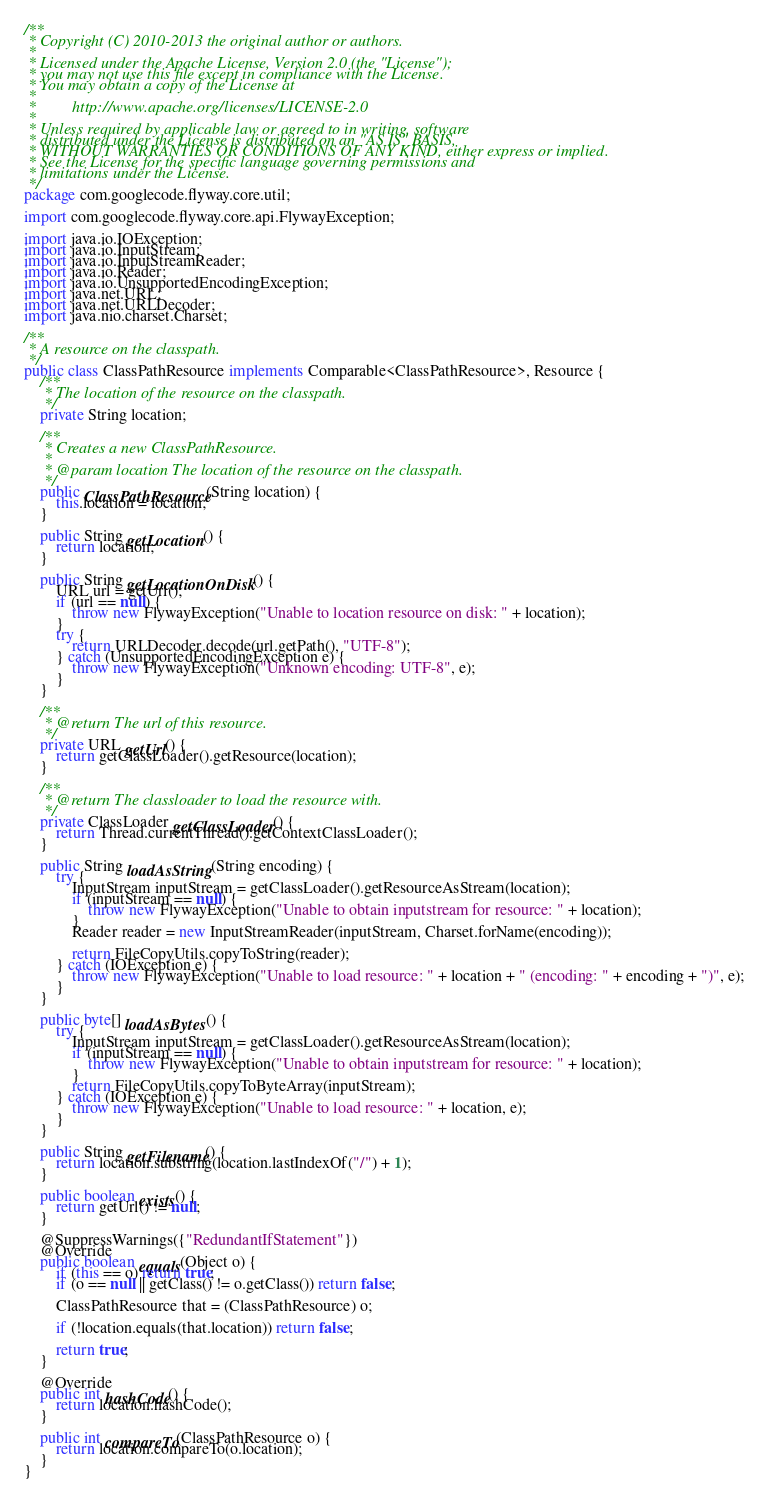Convert code to text. <code><loc_0><loc_0><loc_500><loc_500><_Java_>/**
 * Copyright (C) 2010-2013 the original author or authors.
 *
 * Licensed under the Apache License, Version 2.0 (the "License");
 * you may not use this file except in compliance with the License.
 * You may obtain a copy of the License at
 *
 *         http://www.apache.org/licenses/LICENSE-2.0
 *
 * Unless required by applicable law or agreed to in writing, software
 * distributed under the License is distributed on an "AS IS" BASIS,
 * WITHOUT WARRANTIES OR CONDITIONS OF ANY KIND, either express or implied.
 * See the License for the specific language governing permissions and
 * limitations under the License.
 */
package com.googlecode.flyway.core.util;

import com.googlecode.flyway.core.api.FlywayException;

import java.io.IOException;
import java.io.InputStream;
import java.io.InputStreamReader;
import java.io.Reader;
import java.io.UnsupportedEncodingException;
import java.net.URL;
import java.net.URLDecoder;
import java.nio.charset.Charset;

/**
 * A resource on the classpath.
 */
public class ClassPathResource implements Comparable<ClassPathResource>, Resource {
    /**
     * The location of the resource on the classpath.
     */
    private String location;

    /**
     * Creates a new ClassPathResource.
     *
     * @param location The location of the resource on the classpath.
     */
    public ClassPathResource(String location) {
        this.location = location;
    }

    public String getLocation() {
        return location;
    }

    public String getLocationOnDisk() {
        URL url = getUrl();
        if (url == null) {
            throw new FlywayException("Unable to location resource on disk: " + location);
        }
        try {
            return URLDecoder.decode(url.getPath(), "UTF-8");
        } catch (UnsupportedEncodingException e) {
            throw new FlywayException("Unknown encoding: UTF-8", e);
        }
    }

    /**
     * @return The url of this resource.
     */
    private URL getUrl() {
        return getClassLoader().getResource(location);
    }

    /**
     * @return The classloader to load the resource with.
     */
    private ClassLoader getClassLoader() {
        return Thread.currentThread().getContextClassLoader();
    }

    public String loadAsString(String encoding) {
        try {
            InputStream inputStream = getClassLoader().getResourceAsStream(location);
            if (inputStream == null) {
                throw new FlywayException("Unable to obtain inputstream for resource: " + location);
            }
            Reader reader = new InputStreamReader(inputStream, Charset.forName(encoding));

            return FileCopyUtils.copyToString(reader);
        } catch (IOException e) {
            throw new FlywayException("Unable to load resource: " + location + " (encoding: " + encoding + ")", e);
        }
    }

    public byte[] loadAsBytes() {
        try {
            InputStream inputStream = getClassLoader().getResourceAsStream(location);
            if (inputStream == null) {
                throw new FlywayException("Unable to obtain inputstream for resource: " + location);
            }
            return FileCopyUtils.copyToByteArray(inputStream);
        } catch (IOException e) {
            throw new FlywayException("Unable to load resource: " + location, e);
        }
    }

    public String getFilename() {
        return location.substring(location.lastIndexOf("/") + 1);
    }

    public boolean exists() {
        return getUrl() != null;
    }

    @SuppressWarnings({"RedundantIfStatement"})
    @Override
    public boolean equals(Object o) {
        if (this == o) return true;
        if (o == null || getClass() != o.getClass()) return false;

        ClassPathResource that = (ClassPathResource) o;

        if (!location.equals(that.location)) return false;

        return true;
    }

    @Override
    public int hashCode() {
        return location.hashCode();
    }

    public int compareTo(ClassPathResource o) {
        return location.compareTo(o.location);
    }
}
</code> 